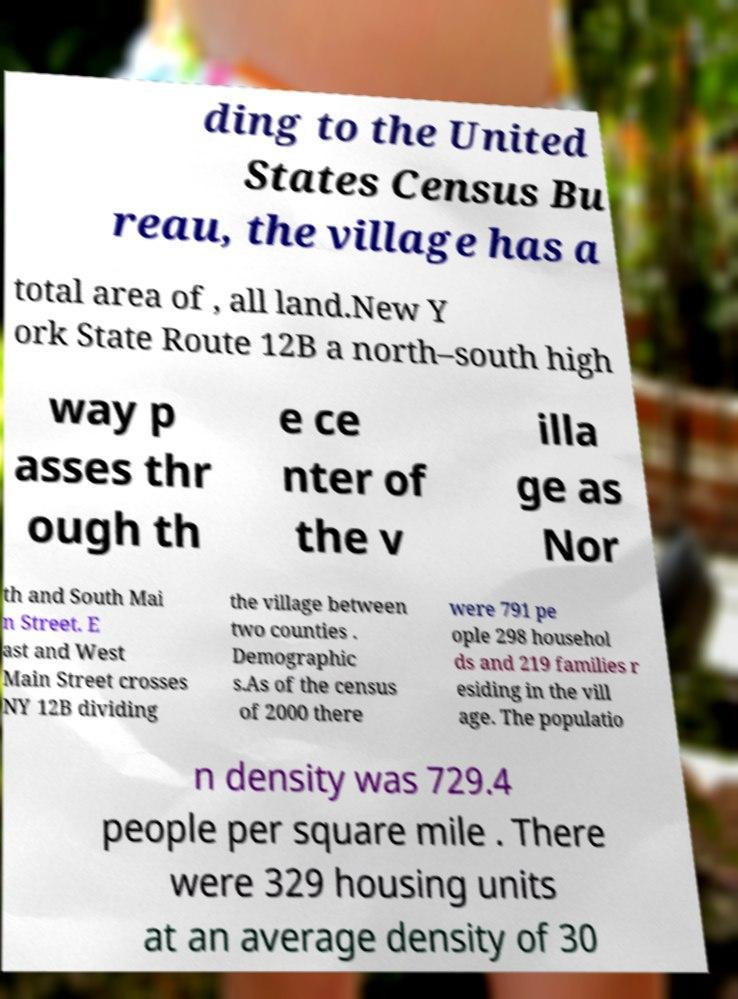Can you accurately transcribe the text from the provided image for me? ding to the United States Census Bu reau, the village has a total area of , all land.New Y ork State Route 12B a north–south high way p asses thr ough th e ce nter of the v illa ge as Nor th and South Mai n Street. E ast and West Main Street crosses NY 12B dividing the village between two counties . Demographic s.As of the census of 2000 there were 791 pe ople 298 househol ds and 219 families r esiding in the vill age. The populatio n density was 729.4 people per square mile . There were 329 housing units at an average density of 30 